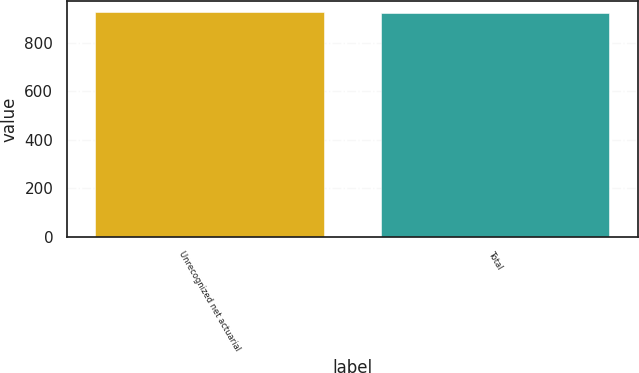Convert chart. <chart><loc_0><loc_0><loc_500><loc_500><bar_chart><fcel>Unrecognized net actuarial<fcel>Total<nl><fcel>927<fcel>925<nl></chart> 